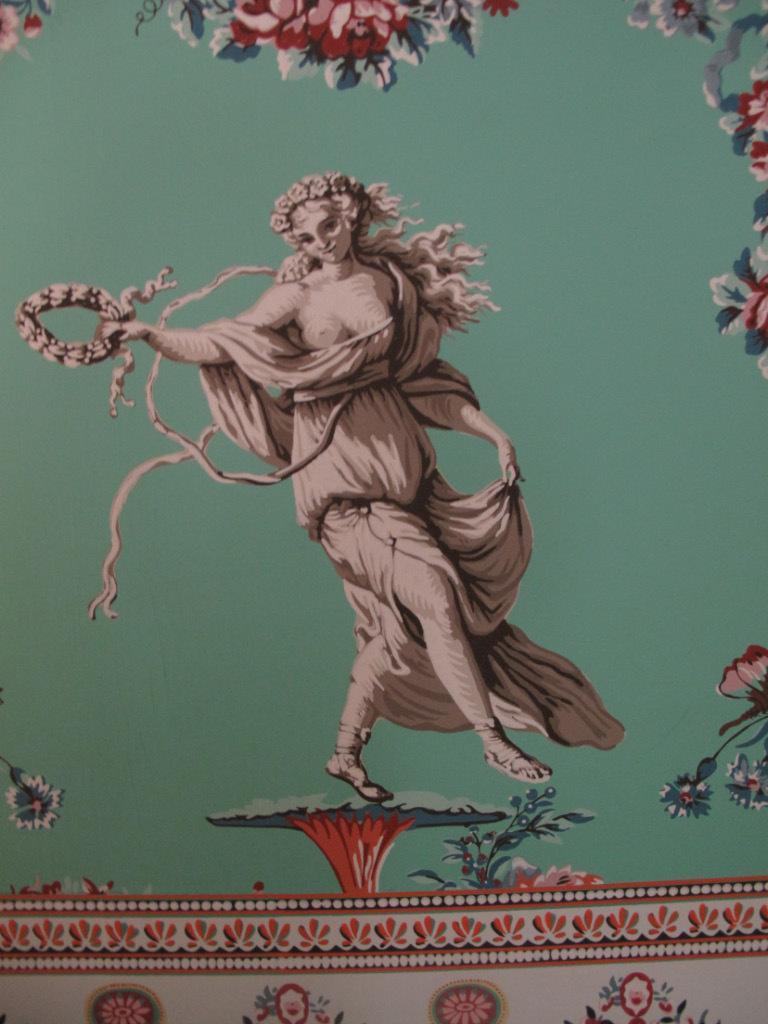In one or two sentences, can you explain what this image depicts? It is a painting. Here we can see a human is holding some objects. Here there are few flowers and leaves. At the bottom, we can see design. 